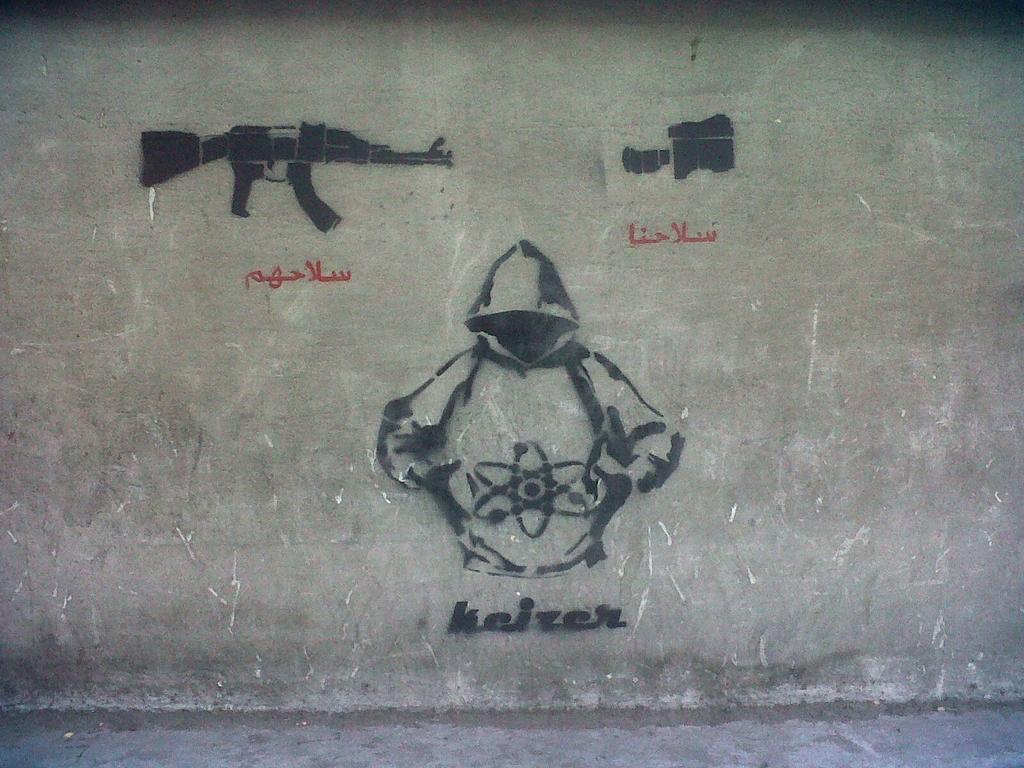Describe this image in one or two sentences. In this image we can see some images and text on the wall. 